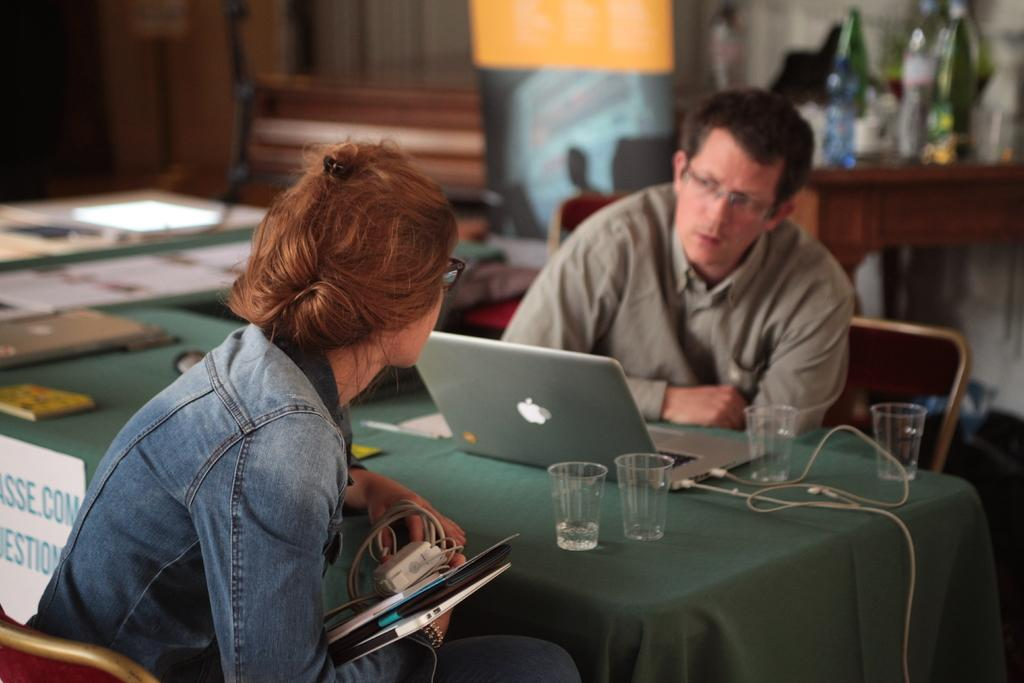How many people are in the image? There are two people in the image. What are the people doing in the image? The people are sitting on chairs. What can be seen on the table in the image? There is a laptop on a table. What objects are near the laptop? There are four glasses near the laptop. Where is the playground located in the image? There is no playground present in the image. What type of toys can be seen near the laptop? There are no toys visible in the image; only four glasses are present near the laptop. 